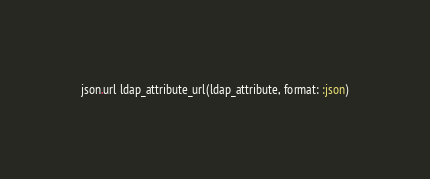<code> <loc_0><loc_0><loc_500><loc_500><_Ruby_>json.url ldap_attribute_url(ldap_attribute, format: :json)
</code> 